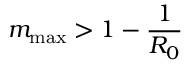Convert formula to latex. <formula><loc_0><loc_0><loc_500><loc_500>m _ { \max } > 1 - \frac { 1 } { R _ { 0 } }</formula> 